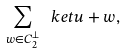<formula> <loc_0><loc_0><loc_500><loc_500>\sum _ { w \in C _ { 2 } ^ { \perp } } \ k e t { u + w } ,</formula> 